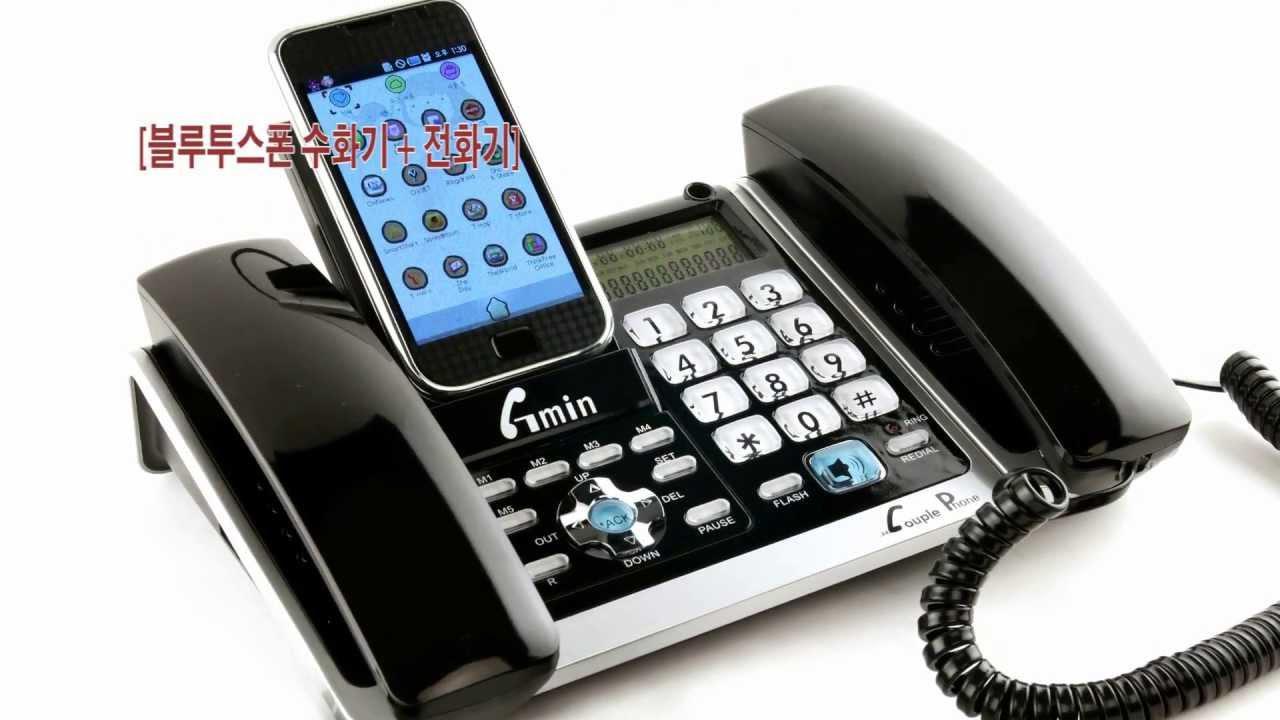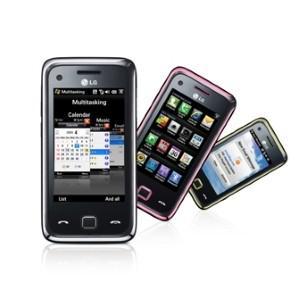The first image is the image on the left, the second image is the image on the right. Examine the images to the left and right. Is the description "There are exactly two phones in the right image." accurate? Answer yes or no. No. The first image is the image on the left, the second image is the image on the right. For the images shown, is this caption "One of the images shows a cell phone docked on a landline phone base." true? Answer yes or no. Yes. 